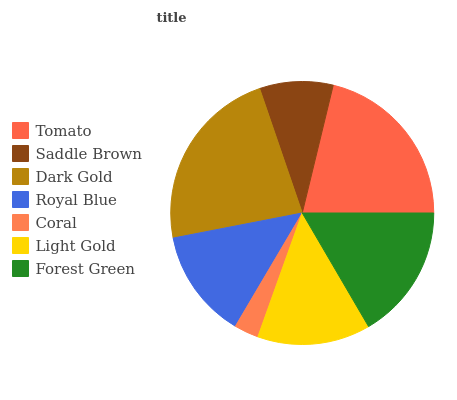Is Coral the minimum?
Answer yes or no. Yes. Is Dark Gold the maximum?
Answer yes or no. Yes. Is Saddle Brown the minimum?
Answer yes or no. No. Is Saddle Brown the maximum?
Answer yes or no. No. Is Tomato greater than Saddle Brown?
Answer yes or no. Yes. Is Saddle Brown less than Tomato?
Answer yes or no. Yes. Is Saddle Brown greater than Tomato?
Answer yes or no. No. Is Tomato less than Saddle Brown?
Answer yes or no. No. Is Light Gold the high median?
Answer yes or no. Yes. Is Light Gold the low median?
Answer yes or no. Yes. Is Saddle Brown the high median?
Answer yes or no. No. Is Tomato the low median?
Answer yes or no. No. 